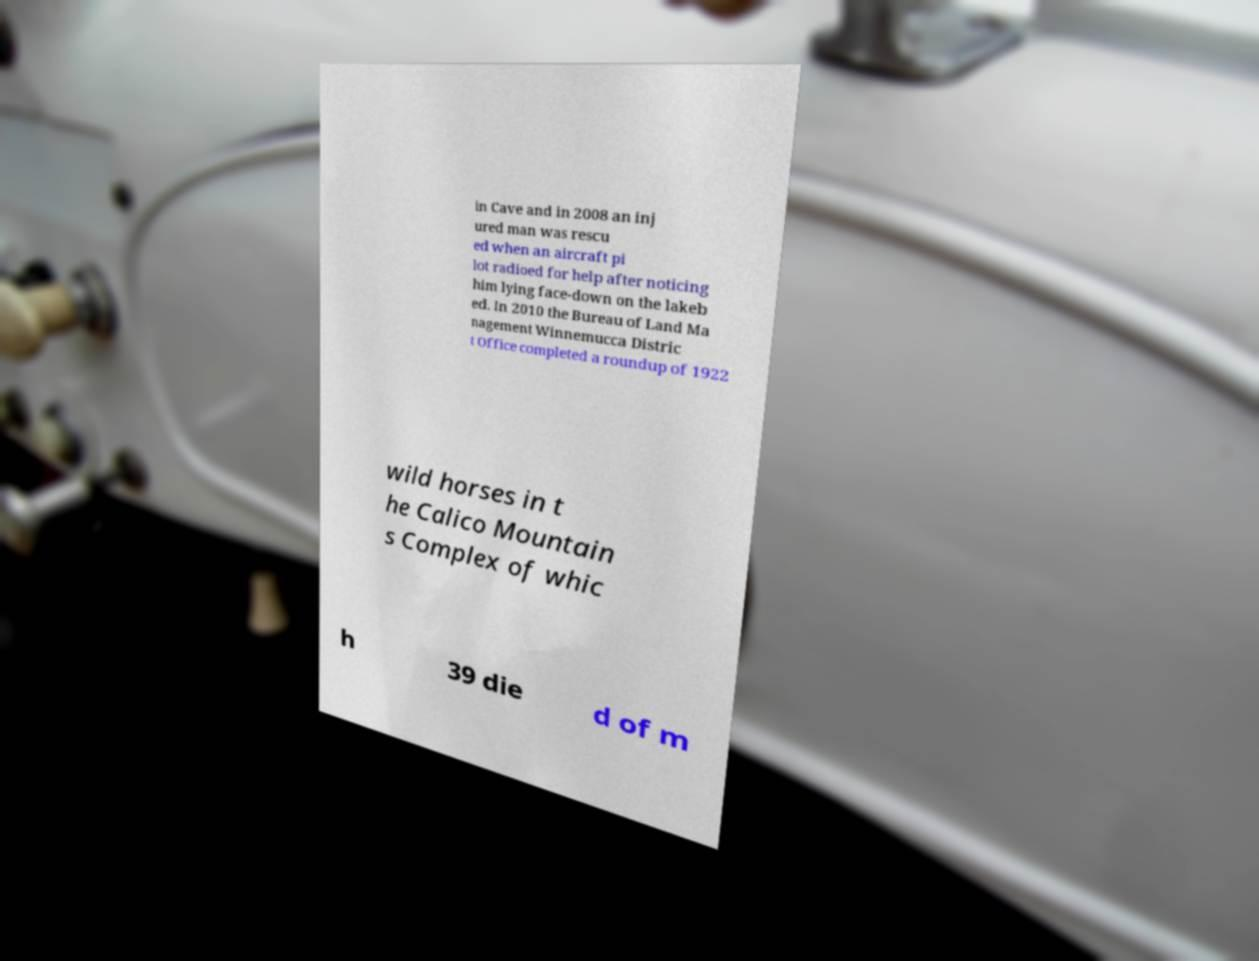What messages or text are displayed in this image? I need them in a readable, typed format. in Cave and in 2008 an inj ured man was rescu ed when an aircraft pi lot radioed for help after noticing him lying face-down on the lakeb ed. In 2010 the Bureau of Land Ma nagement Winnemucca Distric t Office completed a roundup of 1922 wild horses in t he Calico Mountain s Complex of whic h 39 die d of m 